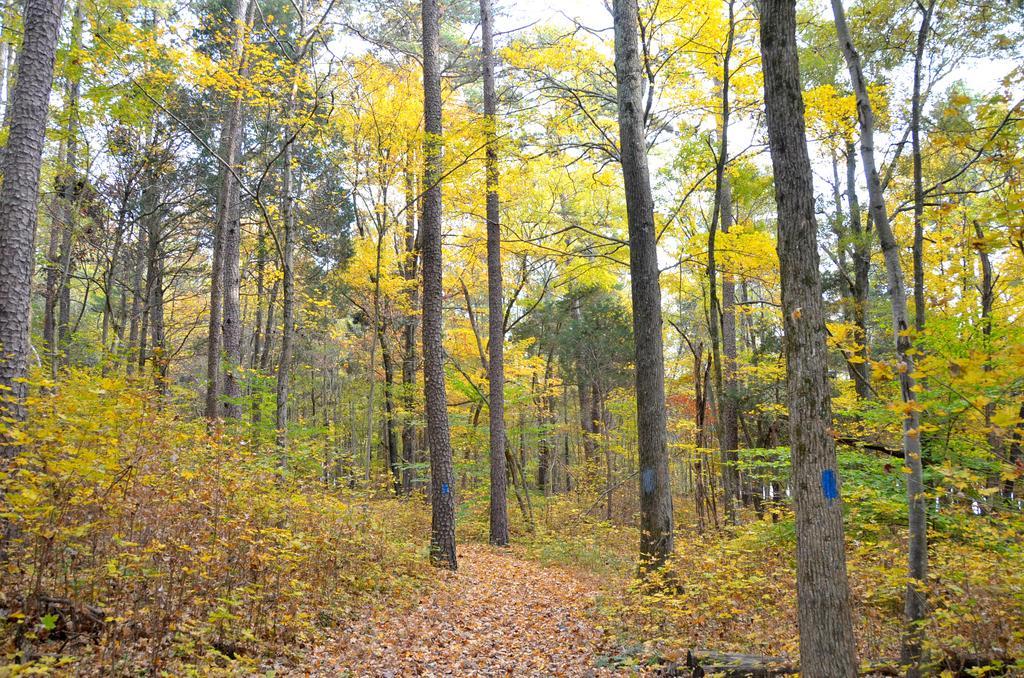Can you describe this image briefly? In this image we can see trees, plants and dried leaves. Through the trees sky is visible. 